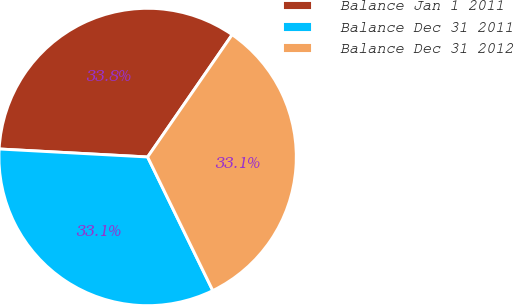<chart> <loc_0><loc_0><loc_500><loc_500><pie_chart><fcel>Balance Jan 1 2011<fcel>Balance Dec 31 2011<fcel>Balance Dec 31 2012<nl><fcel>33.77%<fcel>33.08%<fcel>33.15%<nl></chart> 